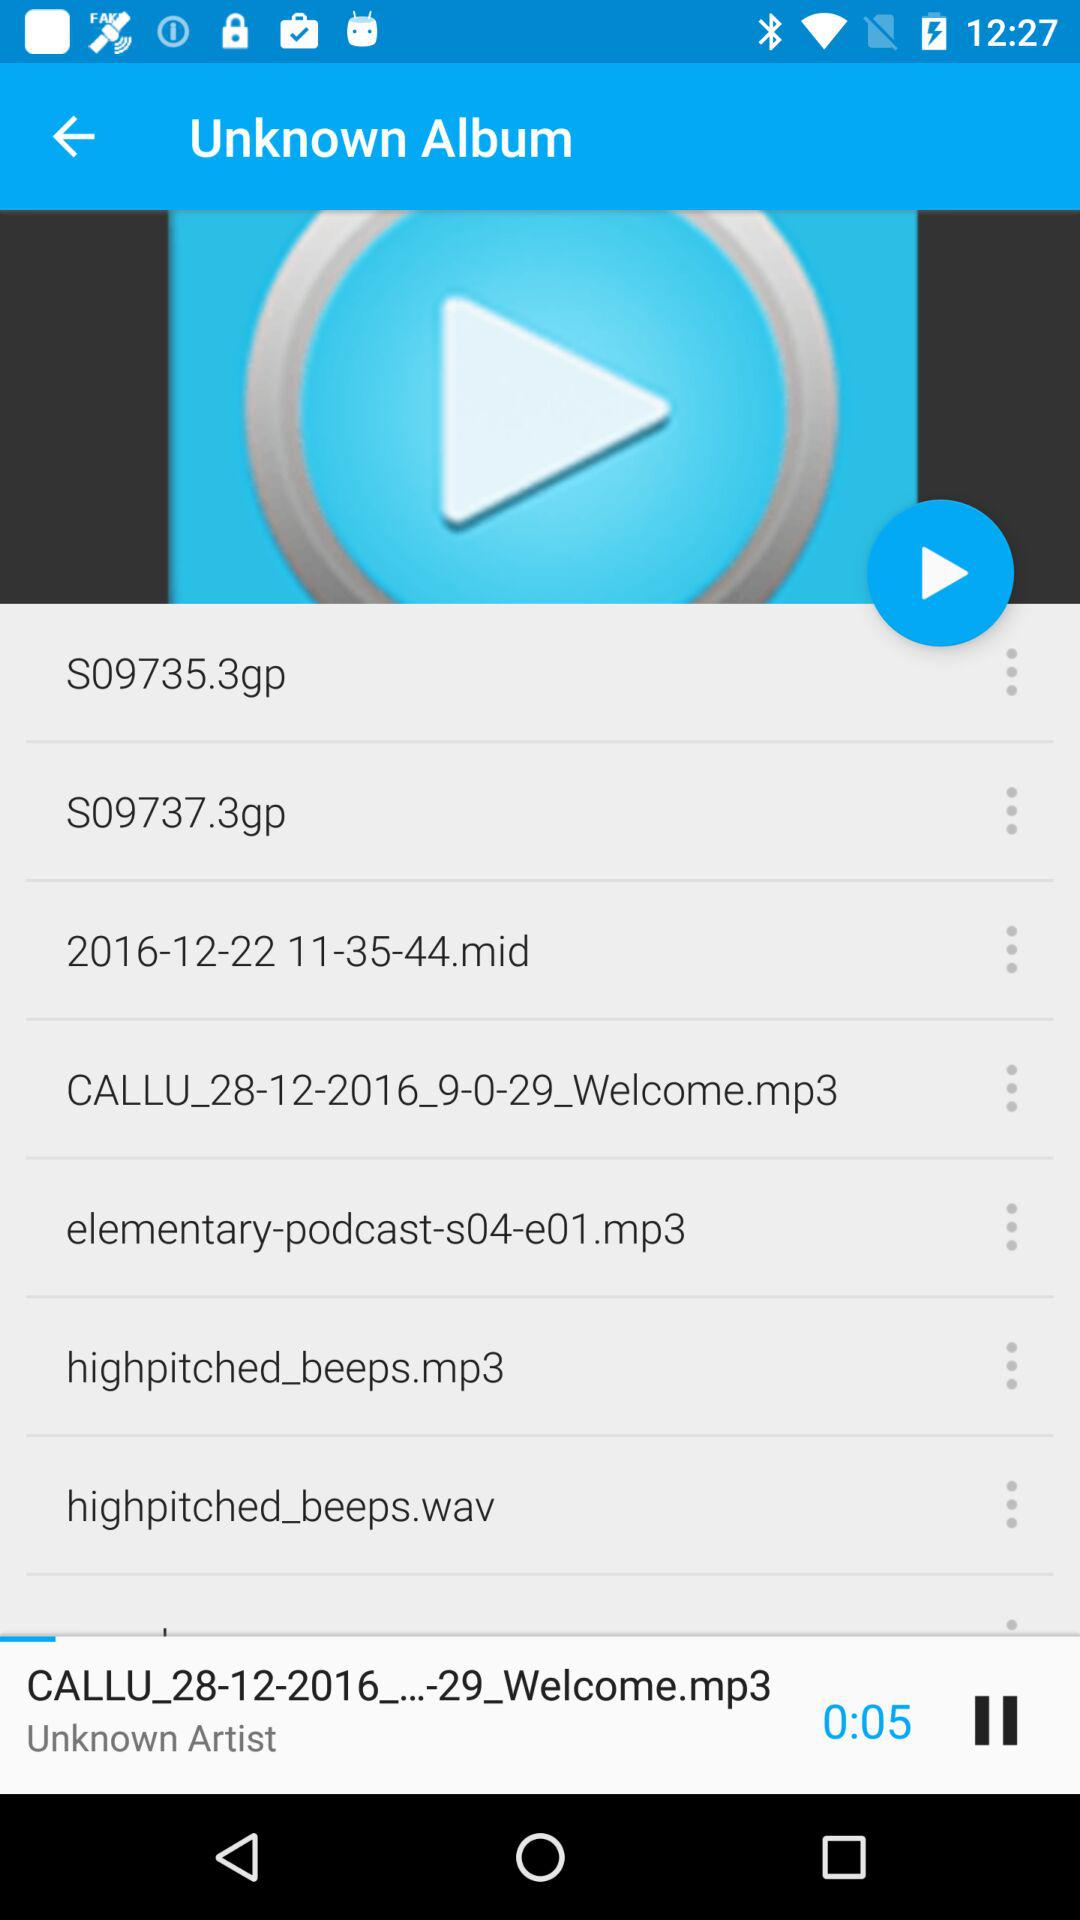What's the album's name? The album's name is Unknown. 